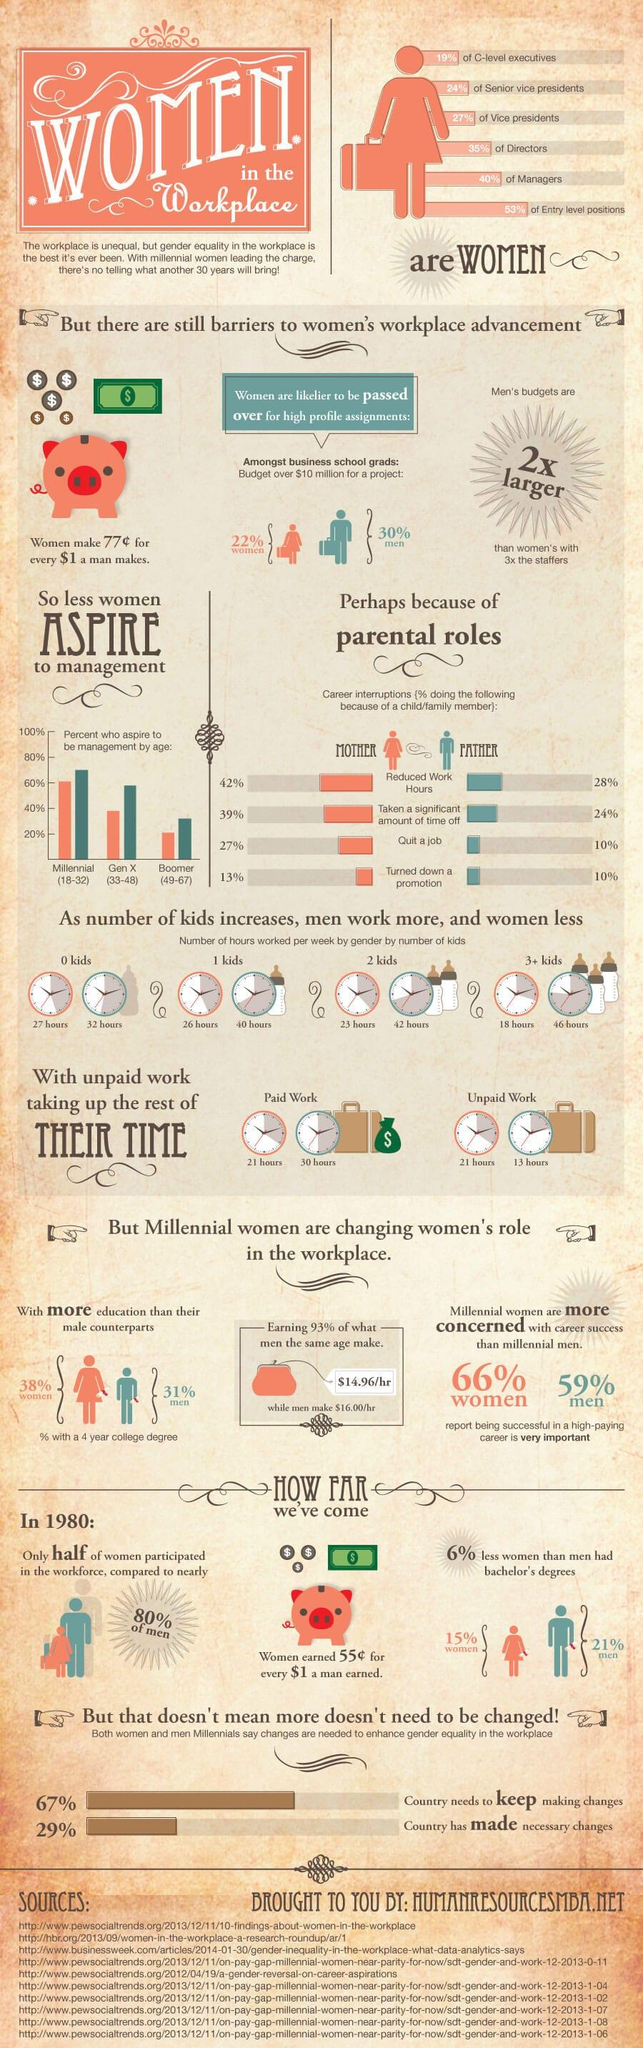Specify some key components in this picture. According to a recent survey, 29% of countries are actively supporting women's empowerment. A recent study has revealed that only 31% of men hold a college degree. The average man works 40 hours per week when raising a single child, according to research. According to a survey of millennial men, 70% aspire to become managers. It is estimated that women who have more than three children typically work for 18 hours per week. 